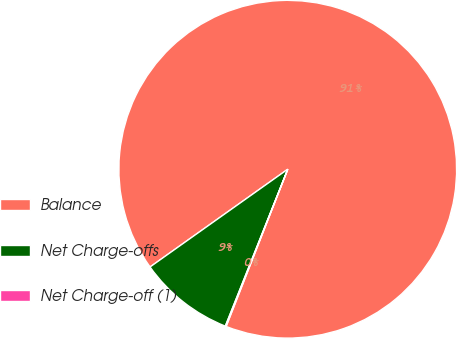Convert chart. <chart><loc_0><loc_0><loc_500><loc_500><pie_chart><fcel>Balance<fcel>Net Charge-offs<fcel>Net Charge-off (1)<nl><fcel>90.77%<fcel>9.15%<fcel>0.08%<nl></chart> 